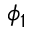<formula> <loc_0><loc_0><loc_500><loc_500>\phi _ { 1 }</formula> 